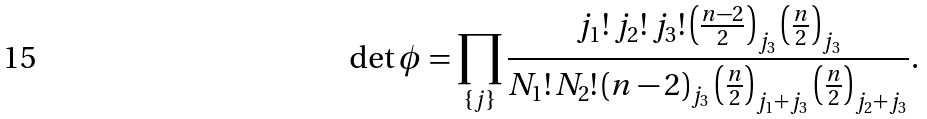Convert formula to latex. <formula><loc_0><loc_0><loc_500><loc_500>\det \phi = \prod _ { \{ j \} } \frac { { j _ { 1 } } ! \, { j _ { 2 } } ! \, { j _ { 3 } } ! \, { \left ( \frac { n - 2 } { 2 } \right ) } _ { j _ { 3 } } \, { \left ( \frac { n } { 2 } \right ) } _ { j _ { 3 } } } { { N _ { 1 } } ! \, { N _ { 2 } } ! \, { ( n - 2 ) } _ { j _ { 3 } } \, { \left ( \frac { n } { 2 } \right ) } _ { j _ { 1 } + j _ { 3 } } \, { \left ( \frac { n } { 2 } \right ) } _ { j _ { 2 } + j _ { 3 } } } .</formula> 